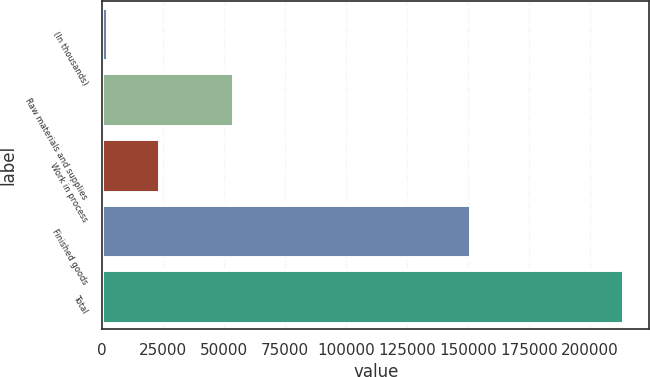<chart> <loc_0><loc_0><loc_500><loc_500><bar_chart><fcel>(In thousands)<fcel>Raw materials and supplies<fcel>Work in process<fcel>Finished goods<fcel>Total<nl><fcel>2007<fcel>53516<fcel>23171.4<fcel>150966<fcel>213651<nl></chart> 